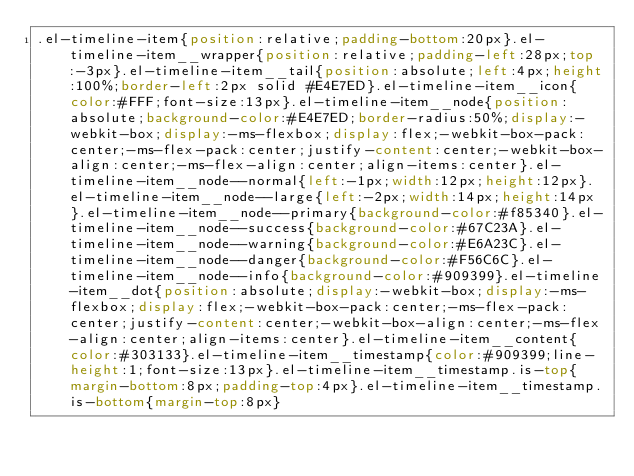Convert code to text. <code><loc_0><loc_0><loc_500><loc_500><_CSS_>.el-timeline-item{position:relative;padding-bottom:20px}.el-timeline-item__wrapper{position:relative;padding-left:28px;top:-3px}.el-timeline-item__tail{position:absolute;left:4px;height:100%;border-left:2px solid #E4E7ED}.el-timeline-item__icon{color:#FFF;font-size:13px}.el-timeline-item__node{position:absolute;background-color:#E4E7ED;border-radius:50%;display:-webkit-box;display:-ms-flexbox;display:flex;-webkit-box-pack:center;-ms-flex-pack:center;justify-content:center;-webkit-box-align:center;-ms-flex-align:center;align-items:center}.el-timeline-item__node--normal{left:-1px;width:12px;height:12px}.el-timeline-item__node--large{left:-2px;width:14px;height:14px}.el-timeline-item__node--primary{background-color:#f85340}.el-timeline-item__node--success{background-color:#67C23A}.el-timeline-item__node--warning{background-color:#E6A23C}.el-timeline-item__node--danger{background-color:#F56C6C}.el-timeline-item__node--info{background-color:#909399}.el-timeline-item__dot{position:absolute;display:-webkit-box;display:-ms-flexbox;display:flex;-webkit-box-pack:center;-ms-flex-pack:center;justify-content:center;-webkit-box-align:center;-ms-flex-align:center;align-items:center}.el-timeline-item__content{color:#303133}.el-timeline-item__timestamp{color:#909399;line-height:1;font-size:13px}.el-timeline-item__timestamp.is-top{margin-bottom:8px;padding-top:4px}.el-timeline-item__timestamp.is-bottom{margin-top:8px}
</code> 